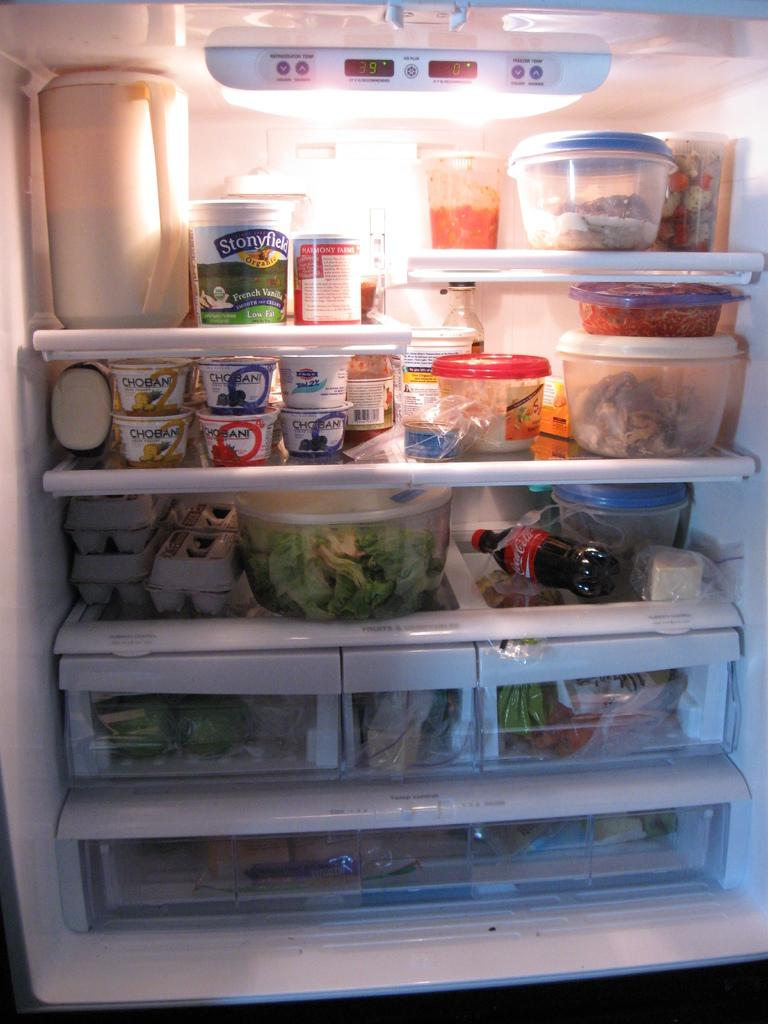<image>
Offer a succinct explanation of the picture presented. An open and full refrigerator has items in it such as Chobani yogurt, eggs, and Coca-Cola. 